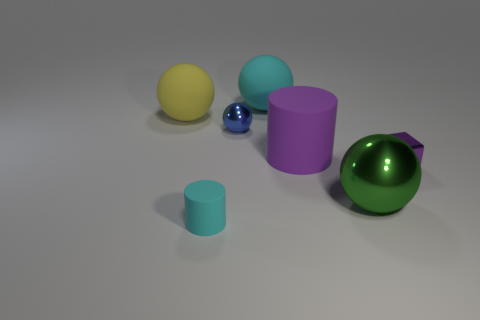Subtract all tiny shiny spheres. How many spheres are left? 3 Add 1 tiny blue shiny objects. How many objects exist? 8 Subtract all blue spheres. How many spheres are left? 3 Subtract all spheres. How many objects are left? 3 Subtract 1 balls. How many balls are left? 3 Subtract all yellow cubes. Subtract all yellow balls. How many cubes are left? 1 Subtract all small cyan rubber objects. Subtract all green metal spheres. How many objects are left? 5 Add 3 big matte objects. How many big matte objects are left? 6 Add 5 small objects. How many small objects exist? 8 Subtract 0 yellow cylinders. How many objects are left? 7 